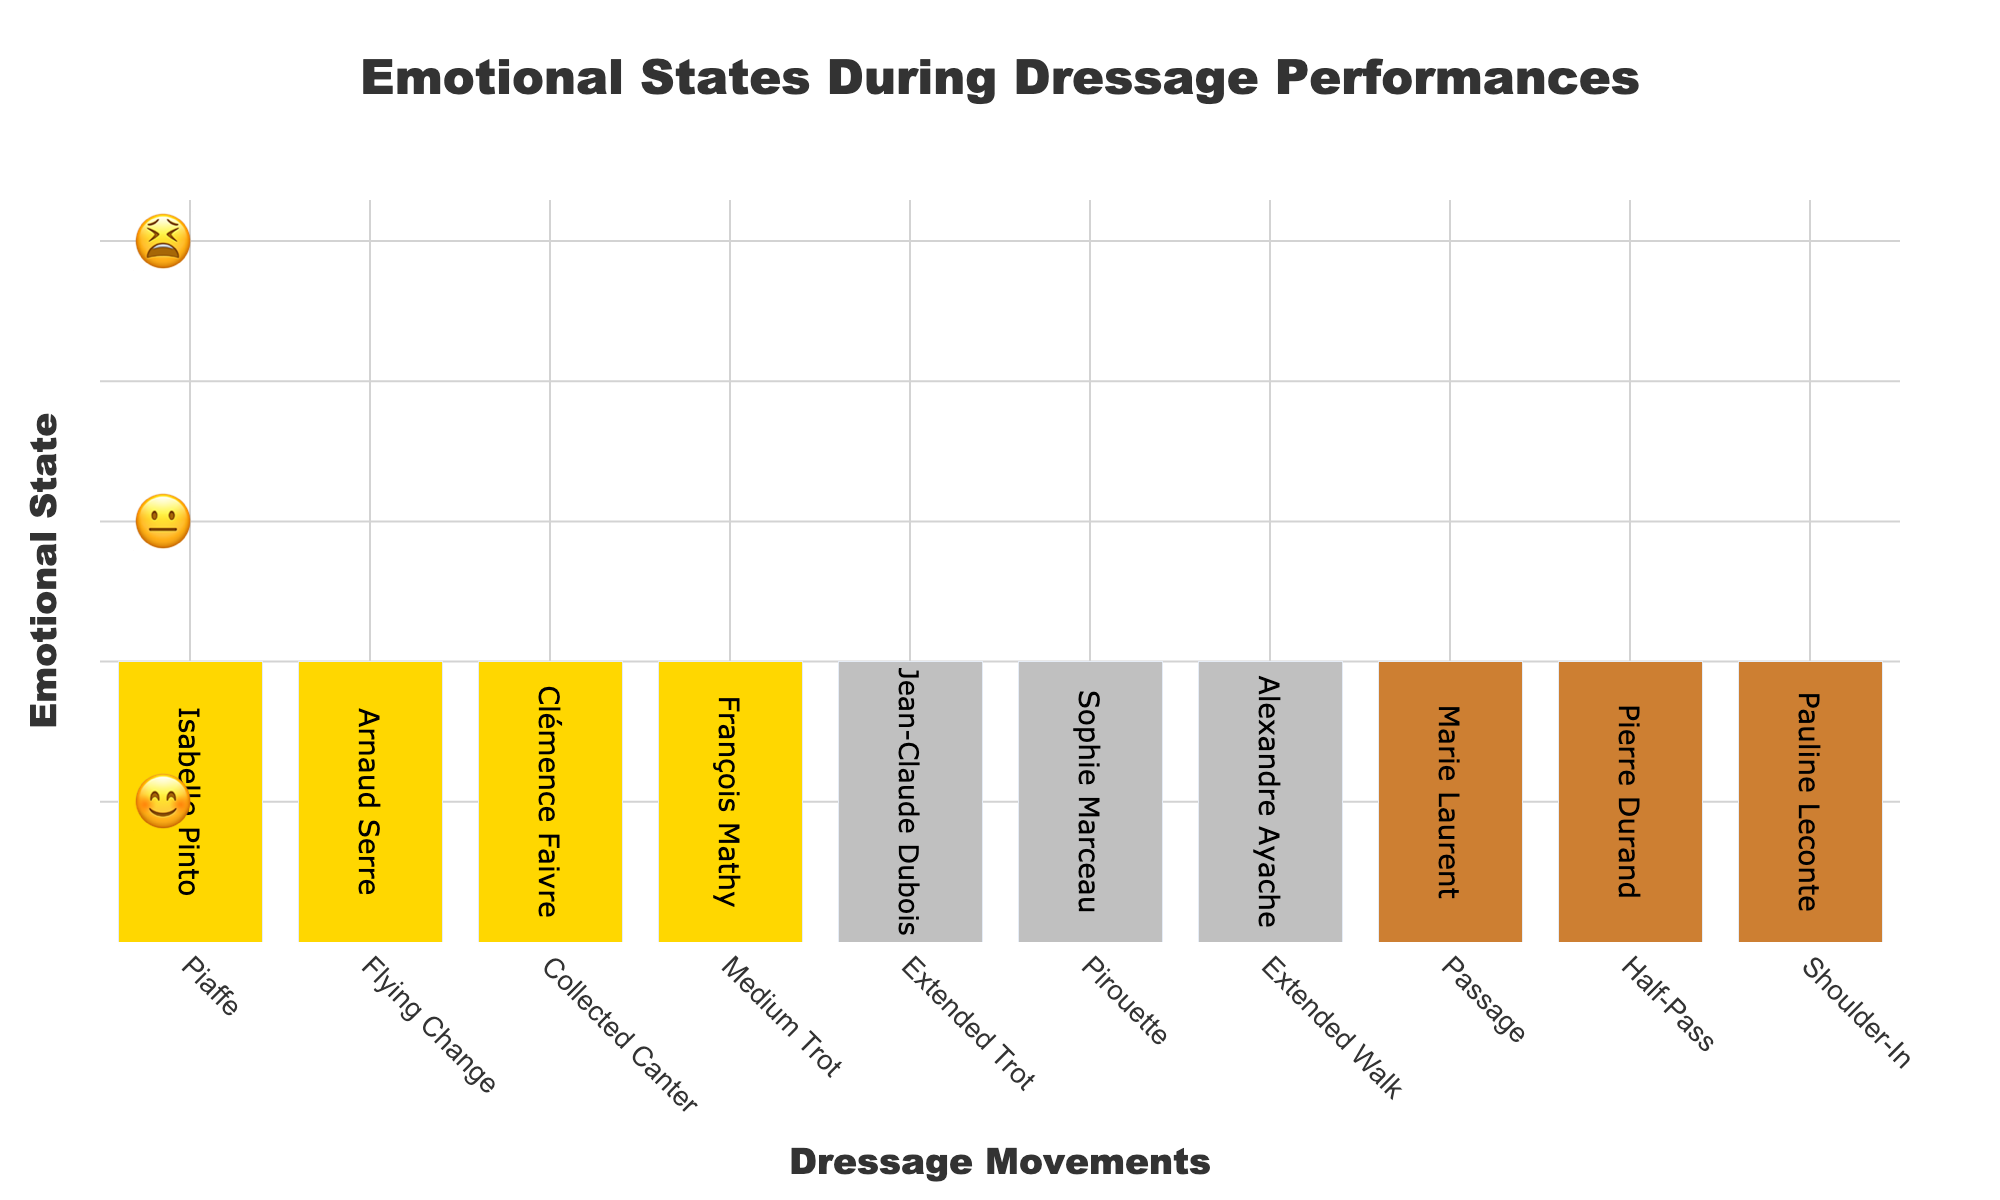What's the title of the chart? The title of the chart is located at the top of the figure and reads: "Emotional States During Dressage Performances".
Answer: Emotional States During Dressage Performances Which dressage movements are associated with the 😊 emoji? The 😊 emoji is associated with the following movements: Piaffe, Flying Change, Collected Canter, Medium Trot.
Answer: Piaffe, Flying Change, Collected Canter, Medium Trot How many riders are feeling 😐 during their performances? By counting the bars under the 😐 emoji, we see there are three riders: Jean-Claude Dubois, Sophie Marceau, and Alexandre Ayache.
Answer: 3 Which rider is associated with the Half-Pass movement? The Half-Pass movement is listed under Pierre Durand's name.
Answer: Pierre Durand How many movements are represented in the chart? Each bar represents a unique movement, so counting all the bars gives us ten movements.
Answer: 10 Which dressage movement is associated with the most negative emotion (😫)? By looking at the 😫 emoji section, we see Passage (Marie Laurent), Half-Pass (Pierre Durand), and Shoulder-In (Pauline Leconte) listed. The Passage movement appears most often with this negative emotion.
Answer: Passage Compare the number of riders showing 😊 versus 😫 emotions. Which group is larger? There are four riders showing 😊 emotions (Isabelle Pinto, Arnaud Serre, Clémence Faivre, François Mathy) and three riders showing 😫 emotions (Marie Laurent, Pierre Durand, Pauline Leconte). The group with 😊 emotions is larger.
Answer: 😊 What kind of emotion does Sophie Marceau exhibit during her Pirouette? Sophie Marceau's Pirouette movement is associated with the 😐 emoji.
Answer: 😐 Can you list all riders and their emotions for the Collected Canter? There is only one rider listed for Collected Canter, Clémence Faivre, who exhibits a 😊 emotion.
Answer: Clémence Faivre, 😊 Which dressage movements are performed by riders showing a neutral (😐) emotion? Neutral (😐) emotion riders perform Extended Trot, Pirouette, and Extended Walk.
Answer: Extended Trot, Pirouette, Extended Walk 